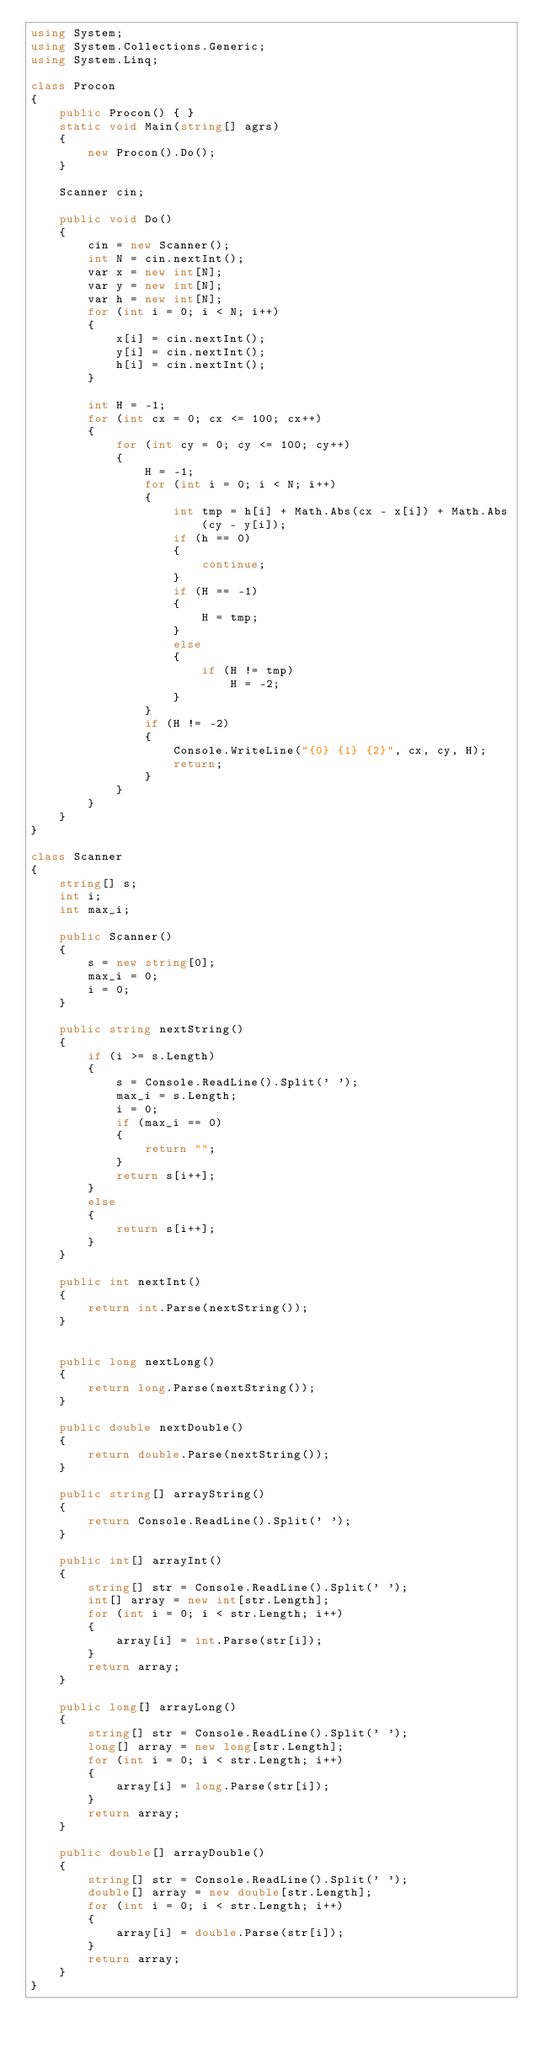<code> <loc_0><loc_0><loc_500><loc_500><_C#_>using System;
using System.Collections.Generic;
using System.Linq;

class Procon
{
    public Procon() { }
    static void Main(string[] agrs)
    {
        new Procon().Do();
    }

    Scanner cin;

    public void Do()
    {
        cin = new Scanner();
        int N = cin.nextInt();
        var x = new int[N];
        var y = new int[N];
        var h = new int[N];
        for (int i = 0; i < N; i++)
        {
            x[i] = cin.nextInt();
            y[i] = cin.nextInt();
            h[i] = cin.nextInt();
        }

        int H = -1;
        for (int cx = 0; cx <= 100; cx++)
        {
            for (int cy = 0; cy <= 100; cy++)
            {
                H = -1;
                for (int i = 0; i < N; i++)
                {
                    int tmp = h[i] + Math.Abs(cx - x[i]) + Math.Abs(cy - y[i]);
                    if (h == 0)
                    {
                        continue;
                    }
                    if (H == -1)
                    {
                        H = tmp;
                    }
                    else
                    {
                        if (H != tmp)
                            H = -2;
                    }
                }
                if (H != -2)
                {
                    Console.WriteLine("{0} {1} {2}", cx, cy, H);
                    return;
                }
            }
        }
    }
}

class Scanner
{
    string[] s;
    int i;
    int max_i;

    public Scanner()
    {
        s = new string[0];
        max_i = 0;
        i = 0;
    }

    public string nextString()
    {
        if (i >= s.Length)
        {
            s = Console.ReadLine().Split(' ');
            max_i = s.Length;
            i = 0;
            if (max_i == 0)
            {
                return "";
            }
            return s[i++];
        }
        else
        {
            return s[i++];
        }
    }

    public int nextInt()
    {
        return int.Parse(nextString());
    }


    public long nextLong()
    {
        return long.Parse(nextString());
    }

    public double nextDouble()
    {
        return double.Parse(nextString());
    }

    public string[] arrayString()
    {
        return Console.ReadLine().Split(' ');
    }

    public int[] arrayInt()
    {
        string[] str = Console.ReadLine().Split(' ');
        int[] array = new int[str.Length];
        for (int i = 0; i < str.Length; i++)
        {
            array[i] = int.Parse(str[i]);
        }
        return array;
    }

    public long[] arrayLong()
    {
        string[] str = Console.ReadLine().Split(' ');
        long[] array = new long[str.Length];
        for (int i = 0; i < str.Length; i++)
        {
            array[i] = long.Parse(str[i]);
        }
        return array;
    }

    public double[] arrayDouble()
    {
        string[] str = Console.ReadLine().Split(' ');
        double[] array = new double[str.Length];
        for (int i = 0; i < str.Length; i++)
        {
            array[i] = double.Parse(str[i]);
        }
        return array;
    }
}
</code> 